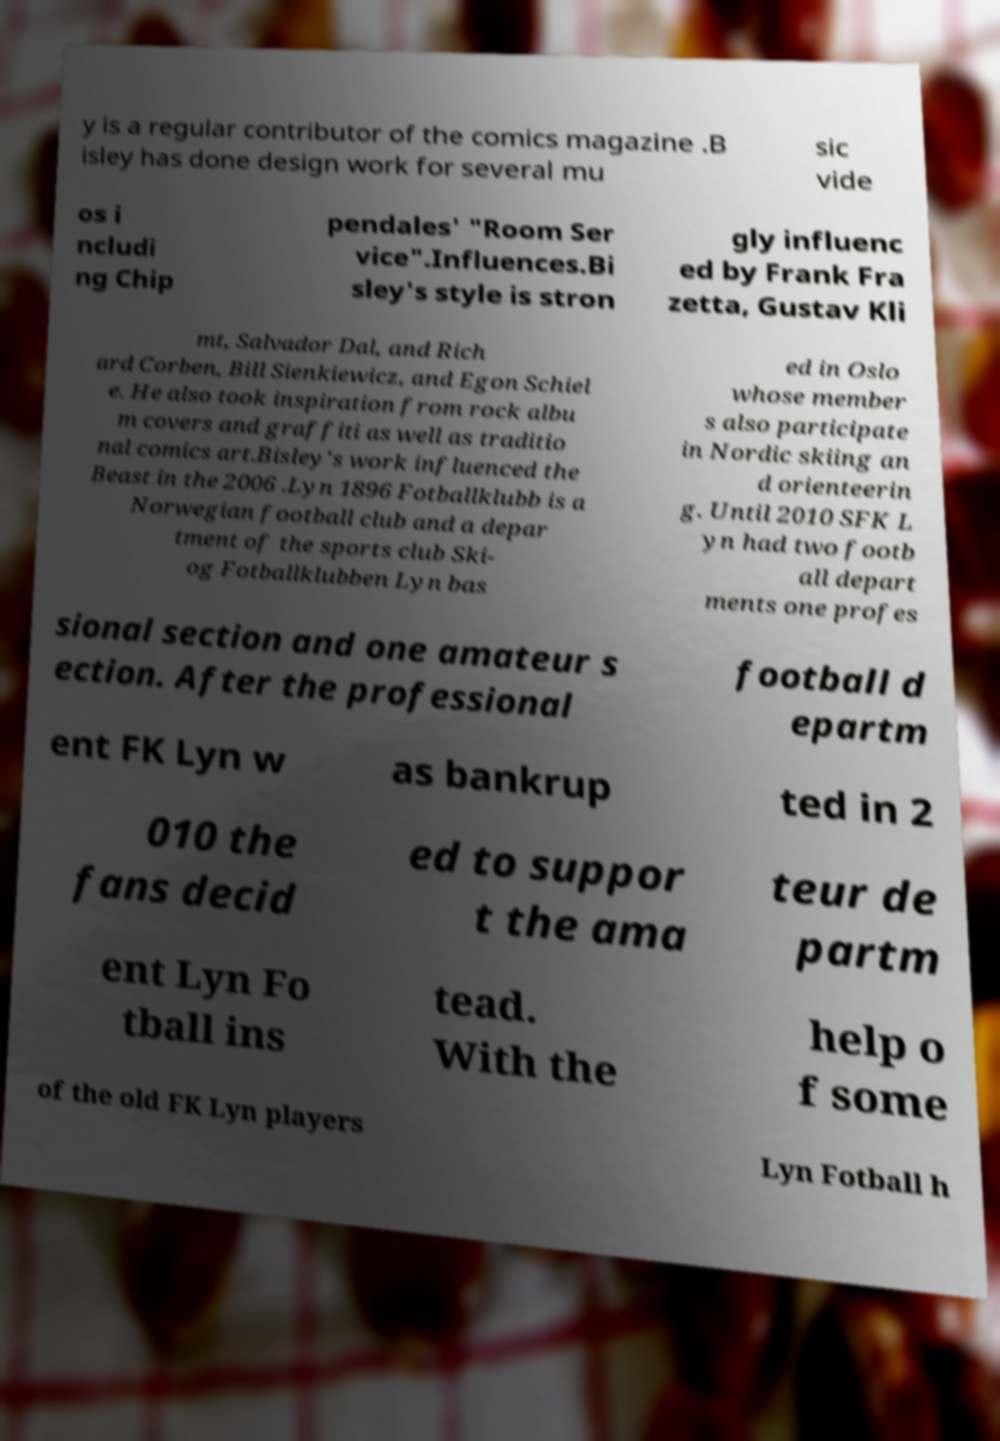I need the written content from this picture converted into text. Can you do that? y is a regular contributor of the comics magazine .B isley has done design work for several mu sic vide os i ncludi ng Chip pendales' "Room Ser vice".Influences.Bi sley's style is stron gly influenc ed by Frank Fra zetta, Gustav Kli mt, Salvador Dal, and Rich ard Corben, Bill Sienkiewicz, and Egon Schiel e. He also took inspiration from rock albu m covers and graffiti as well as traditio nal comics art.Bisley's work influenced the Beast in the 2006 .Lyn 1896 Fotballklubb is a Norwegian football club and a depar tment of the sports club Ski- og Fotballklubben Lyn bas ed in Oslo whose member s also participate in Nordic skiing an d orienteerin g. Until 2010 SFK L yn had two footb all depart ments one profes sional section and one amateur s ection. After the professional football d epartm ent FK Lyn w as bankrup ted in 2 010 the fans decid ed to suppor t the ama teur de partm ent Lyn Fo tball ins tead. With the help o f some of the old FK Lyn players Lyn Fotball h 